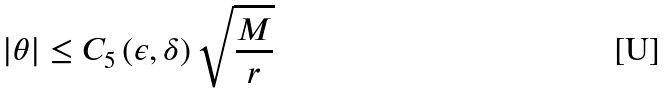Convert formula to latex. <formula><loc_0><loc_0><loc_500><loc_500>| \theta | \leq C _ { 5 } \left ( \epsilon , \delta \right ) \sqrt { \frac { M } { r } }</formula> 